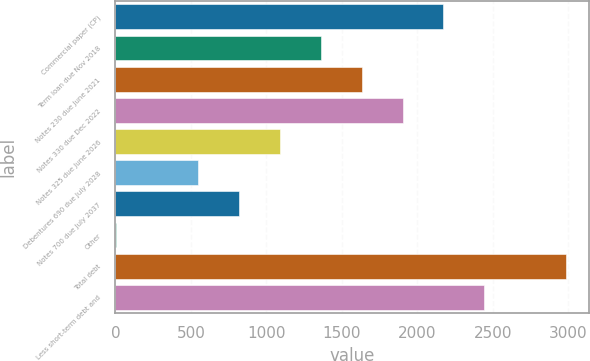Convert chart to OTSL. <chart><loc_0><loc_0><loc_500><loc_500><bar_chart><fcel>Commercial paper (CP)<fcel>Term loan due Nov 2018<fcel>Notes 230 due June 2021<fcel>Notes 330 due Dec 2022<fcel>Notes 325 due June 2026<fcel>Debentures 690 due July 2028<fcel>Notes 700 due July 2037<fcel>Other<fcel>Total debt<fcel>Less short-term debt and<nl><fcel>2172.78<fcel>1359<fcel>1630.26<fcel>1901.52<fcel>1087.74<fcel>545.22<fcel>816.48<fcel>2.7<fcel>2986.56<fcel>2444.04<nl></chart> 